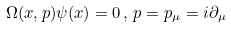Convert formula to latex. <formula><loc_0><loc_0><loc_500><loc_500>\Omega ( x , p ) \psi ( x ) = 0 \, , \, p = p _ { \mu } = i \partial _ { \mu }</formula> 